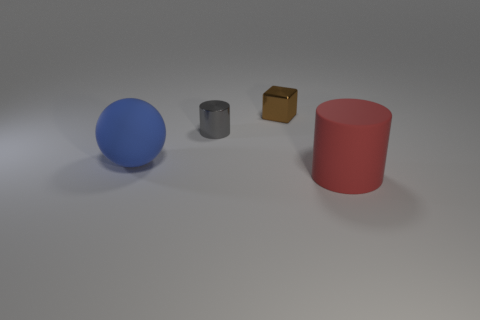Add 2 shiny cylinders. How many objects exist? 6 Subtract all balls. How many objects are left? 3 Subtract all big brown rubber spheres. Subtract all big balls. How many objects are left? 3 Add 2 matte cylinders. How many matte cylinders are left? 3 Add 1 big things. How many big things exist? 3 Subtract 0 yellow cylinders. How many objects are left? 4 